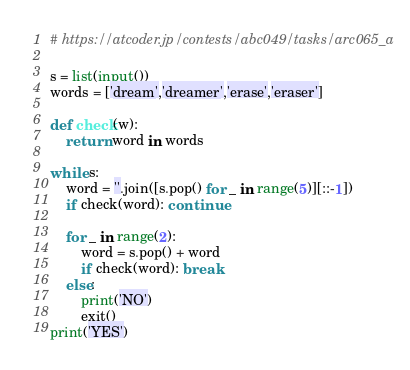Convert code to text. <code><loc_0><loc_0><loc_500><loc_500><_Python_># https://atcoder.jp/contests/abc049/tasks/arc065_a

s = list(input())
words = ['dream','dreamer','erase','eraser']

def check(w):
    return word in words

while s:
    word = ''.join([s.pop() for _ in range(5)][::-1])
    if check(word): continue
    
    for _ in range(2):
        word = s.pop() + word
        if check(word): break
    else:
        print('NO')
        exit()
print('YES')</code> 